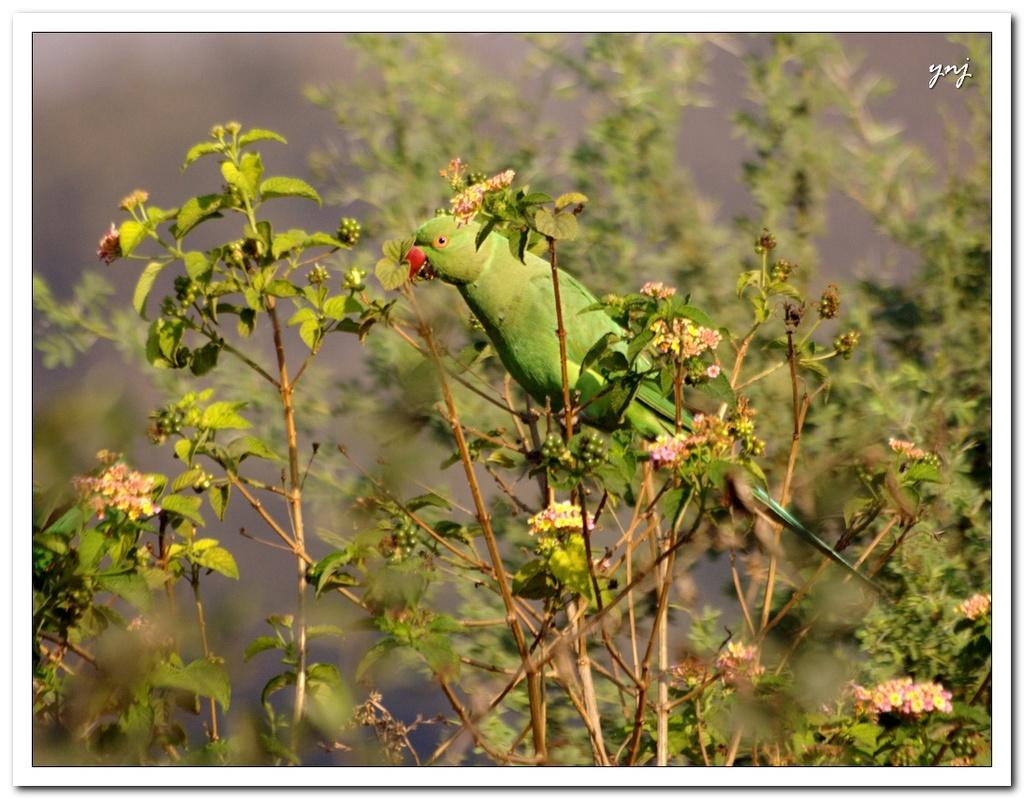What types of plants are visible in the image? There are plants with fruits and flowers in the image. What animal can be seen in the image? There is a parrot in the image. How would you describe the background of the image? The background of the image is blurred. Where is the text located in the image? The text is in the right top corner of the image. What type of lunchroom can be seen in the image? There is no lunchroom present in the image. How many stars are visible in the image? There are no stars visible in the image. 